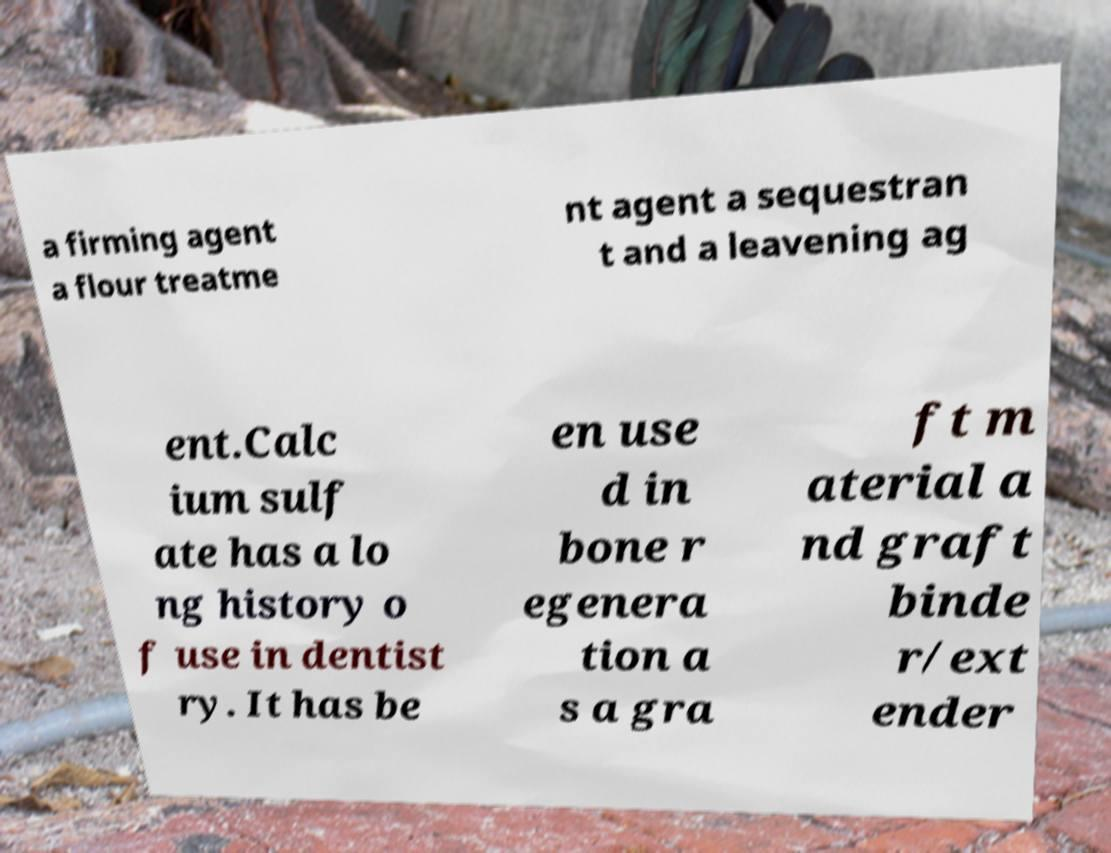I need the written content from this picture converted into text. Can you do that? a firming agent a flour treatme nt agent a sequestran t and a leavening ag ent.Calc ium sulf ate has a lo ng history o f use in dentist ry. It has be en use d in bone r egenera tion a s a gra ft m aterial a nd graft binde r/ext ender 